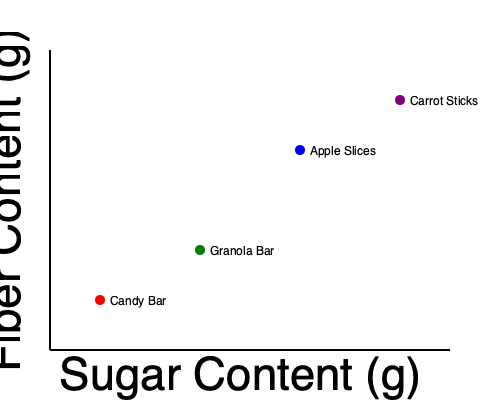Based on the scatter plot showing the relationship between sugar content and fiber content in various snacks, which snack option would be the best choice for a parent looking to provide a healthier alternative that still satisfies a child's sweet craving? To answer this question, we need to analyze the scatter plot and consider both the sugar and fiber content of each snack option:

1. Identify the axes:
   - X-axis represents sugar content (g)
   - Y-axis represents fiber content (g)

2. Analyze each snack option:
   a) Candy Bar: High sugar content, low fiber content
   b) Granola Bar: Moderate sugar content, moderate fiber content
   c) Apple Slices: Lower sugar content, higher fiber content
   d) Carrot Sticks: Lowest sugar content, highest fiber content

3. Consider the parent's goal:
   - Provide a healthier alternative
   - Still satisfy the child's sweet craving

4. Evaluate the options:
   - Candy Bar: Not a healthy option due to high sugar and low fiber
   - Carrot Sticks: Healthiest option but may not satisfy sweet cravings
   - Apple Slices: Good balance of lower sugar and higher fiber, while still providing natural sweetness
   - Granola Bar: Moderate in both sugar and fiber, could be a compromise

5. Make a decision:
   Apple Slices offer the best balance between health benefits (higher fiber, lower sugar) and satisfying sweet cravings with natural sugars.
Answer: Apple Slices 